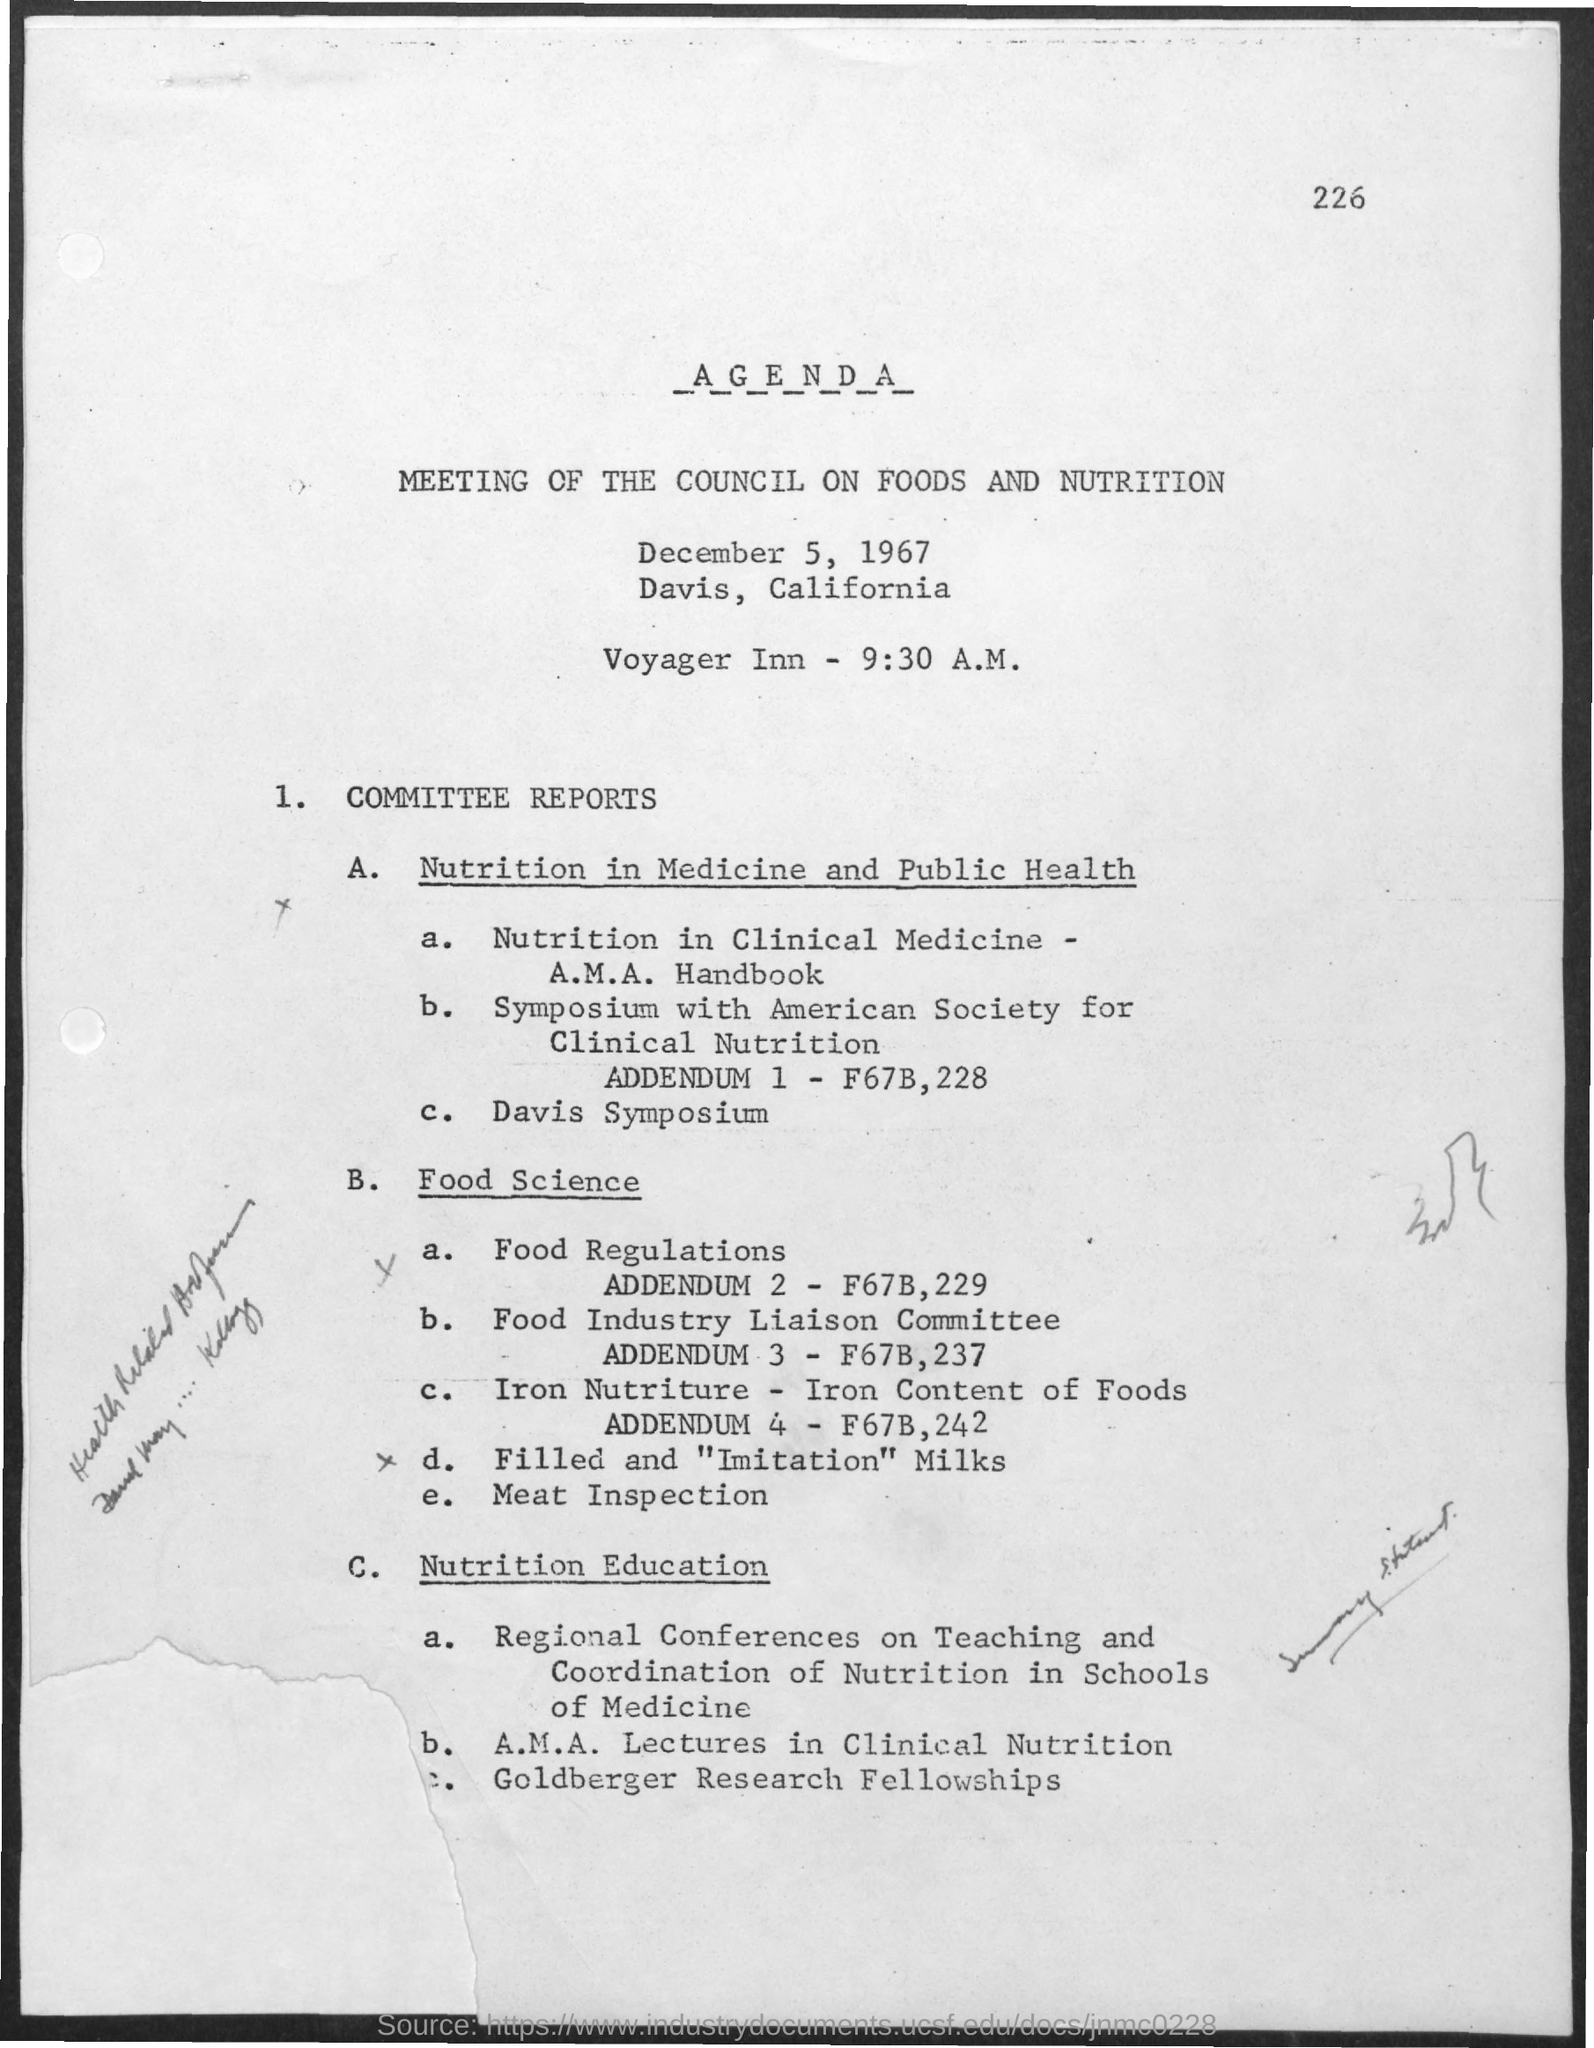Give some essential details in this illustration. The time mentioned in the document is 9:30 A.M. The date mentioned in the document is December 5, 1967. The first title in the document is 'a g e n d a...' The second title in the document is "Meeting of the council on foods and nutrition. The page number is 226. 